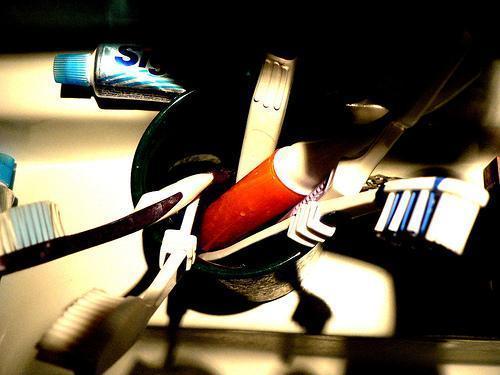How many brushes are there?
Give a very brief answer. 6. 